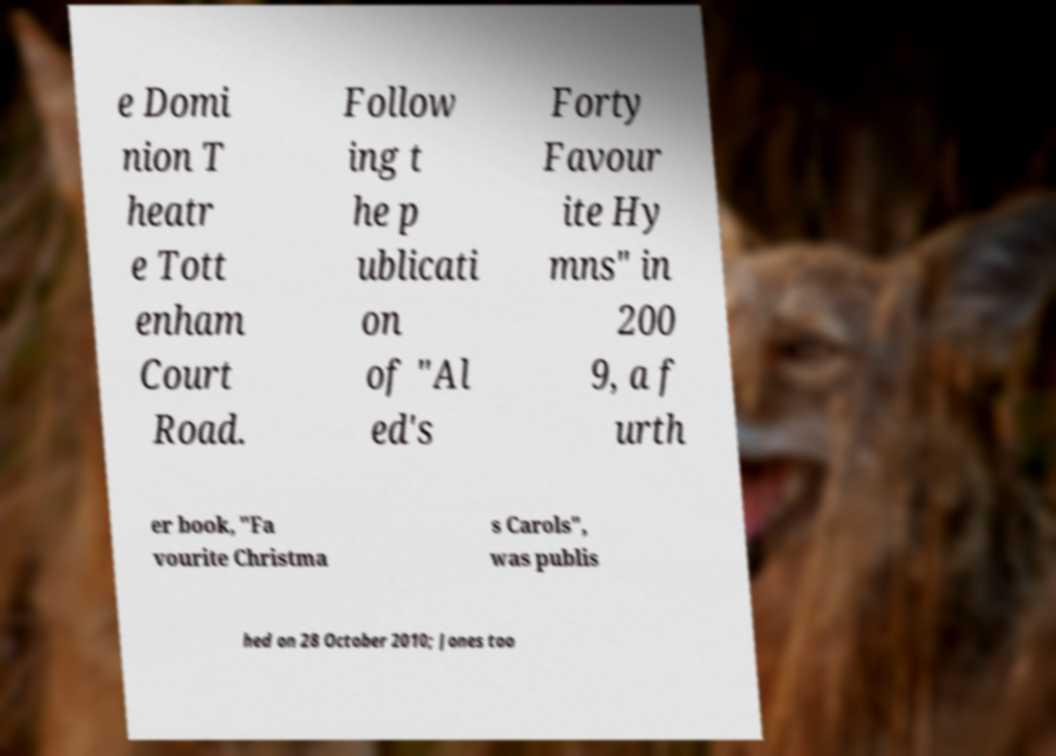Could you extract and type out the text from this image? e Domi nion T heatr e Tott enham Court Road. Follow ing t he p ublicati on of "Al ed's Forty Favour ite Hy mns" in 200 9, a f urth er book, "Fa vourite Christma s Carols", was publis hed on 28 October 2010; Jones too 